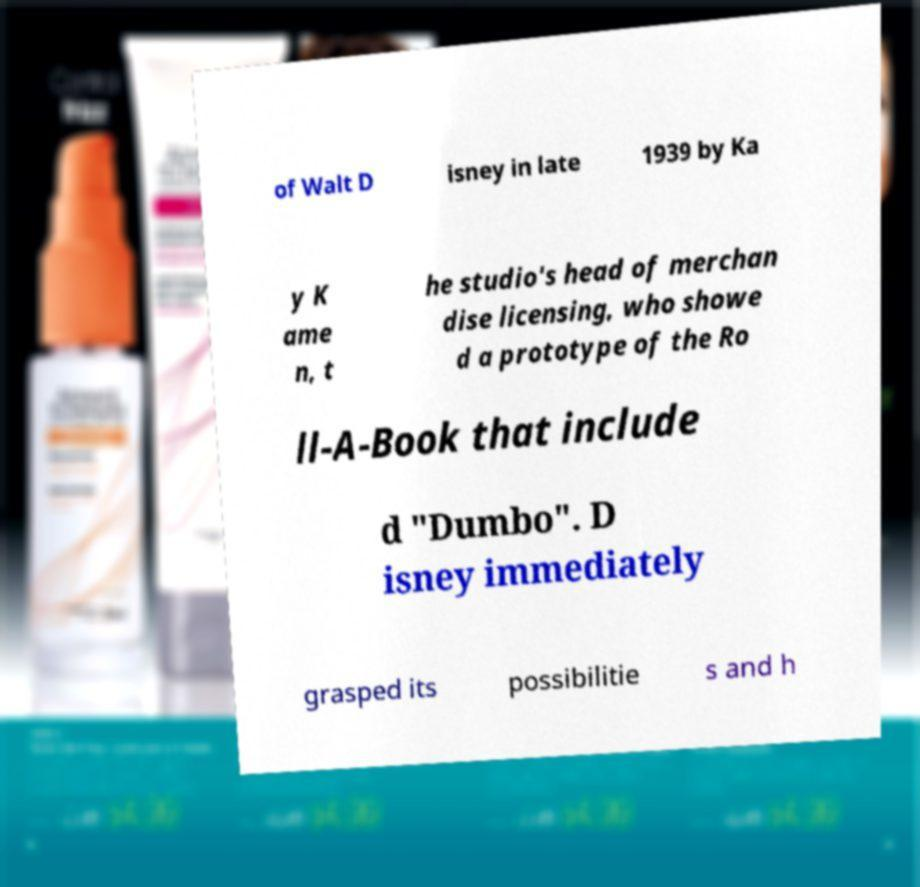Can you read and provide the text displayed in the image?This photo seems to have some interesting text. Can you extract and type it out for me? of Walt D isney in late 1939 by Ka y K ame n, t he studio's head of merchan dise licensing, who showe d a prototype of the Ro ll-A-Book that include d "Dumbo". D isney immediately grasped its possibilitie s and h 